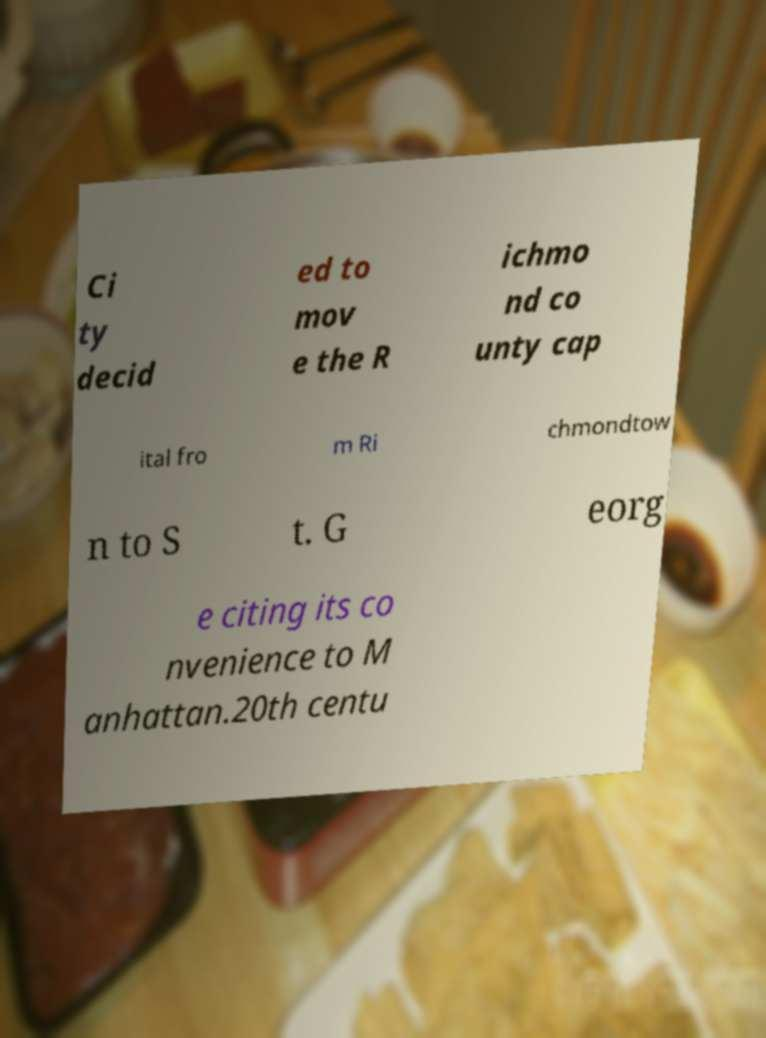Can you accurately transcribe the text from the provided image for me? Ci ty decid ed to mov e the R ichmo nd co unty cap ital fro m Ri chmondtow n to S t. G eorg e citing its co nvenience to M anhattan.20th centu 